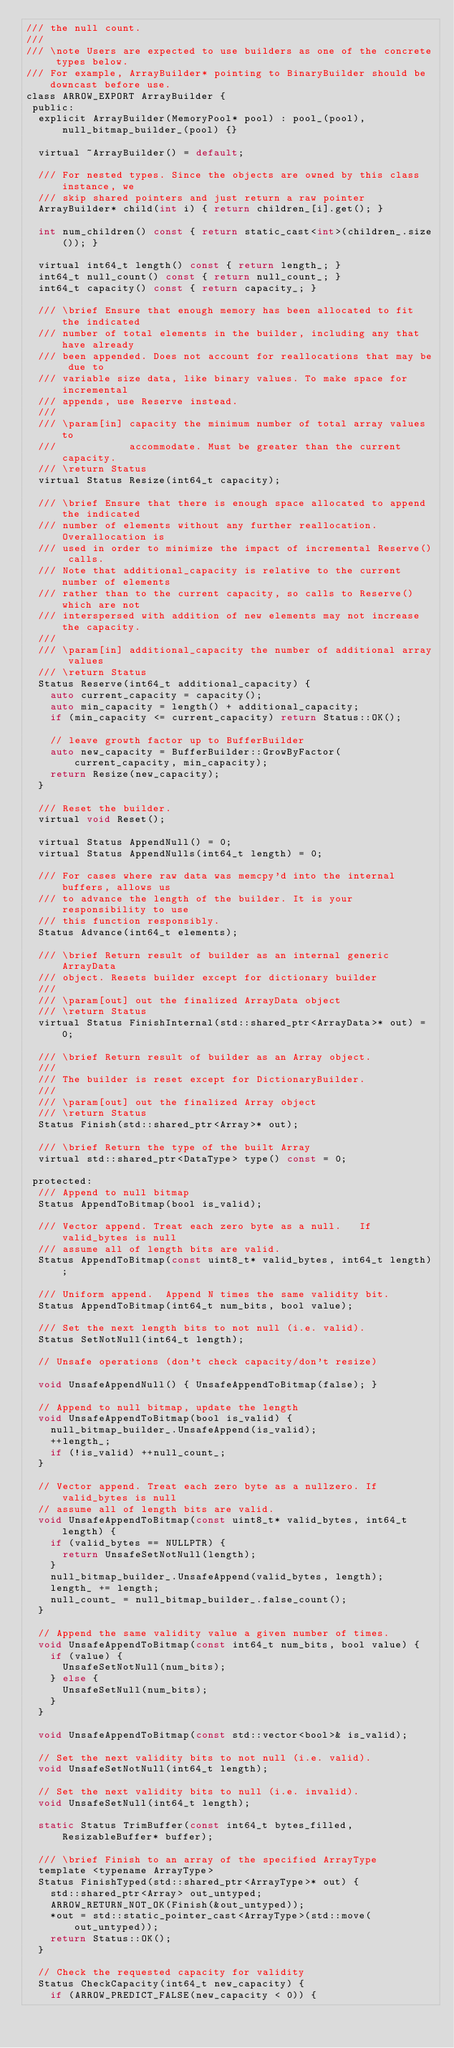Convert code to text. <code><loc_0><loc_0><loc_500><loc_500><_C_>/// the null count.
///
/// \note Users are expected to use builders as one of the concrete types below.
/// For example, ArrayBuilder* pointing to BinaryBuilder should be downcast before use.
class ARROW_EXPORT ArrayBuilder {
 public:
  explicit ArrayBuilder(MemoryPool* pool) : pool_(pool), null_bitmap_builder_(pool) {}

  virtual ~ArrayBuilder() = default;

  /// For nested types. Since the objects are owned by this class instance, we
  /// skip shared pointers and just return a raw pointer
  ArrayBuilder* child(int i) { return children_[i].get(); }

  int num_children() const { return static_cast<int>(children_.size()); }

  virtual int64_t length() const { return length_; }
  int64_t null_count() const { return null_count_; }
  int64_t capacity() const { return capacity_; }

  /// \brief Ensure that enough memory has been allocated to fit the indicated
  /// number of total elements in the builder, including any that have already
  /// been appended. Does not account for reallocations that may be due to
  /// variable size data, like binary values. To make space for incremental
  /// appends, use Reserve instead.
  ///
  /// \param[in] capacity the minimum number of total array values to
  ///            accommodate. Must be greater than the current capacity.
  /// \return Status
  virtual Status Resize(int64_t capacity);

  /// \brief Ensure that there is enough space allocated to append the indicated
  /// number of elements without any further reallocation. Overallocation is
  /// used in order to minimize the impact of incremental Reserve() calls.
  /// Note that additional_capacity is relative to the current number of elements
  /// rather than to the current capacity, so calls to Reserve() which are not
  /// interspersed with addition of new elements may not increase the capacity.
  ///
  /// \param[in] additional_capacity the number of additional array values
  /// \return Status
  Status Reserve(int64_t additional_capacity) {
    auto current_capacity = capacity();
    auto min_capacity = length() + additional_capacity;
    if (min_capacity <= current_capacity) return Status::OK();

    // leave growth factor up to BufferBuilder
    auto new_capacity = BufferBuilder::GrowByFactor(current_capacity, min_capacity);
    return Resize(new_capacity);
  }

  /// Reset the builder.
  virtual void Reset();

  virtual Status AppendNull() = 0;
  virtual Status AppendNulls(int64_t length) = 0;

  /// For cases where raw data was memcpy'd into the internal buffers, allows us
  /// to advance the length of the builder. It is your responsibility to use
  /// this function responsibly.
  Status Advance(int64_t elements);

  /// \brief Return result of builder as an internal generic ArrayData
  /// object. Resets builder except for dictionary builder
  ///
  /// \param[out] out the finalized ArrayData object
  /// \return Status
  virtual Status FinishInternal(std::shared_ptr<ArrayData>* out) = 0;

  /// \brief Return result of builder as an Array object.
  ///
  /// The builder is reset except for DictionaryBuilder.
  ///
  /// \param[out] out the finalized Array object
  /// \return Status
  Status Finish(std::shared_ptr<Array>* out);

  /// \brief Return the type of the built Array
  virtual std::shared_ptr<DataType> type() const = 0;

 protected:
  /// Append to null bitmap
  Status AppendToBitmap(bool is_valid);

  /// Vector append. Treat each zero byte as a null.   If valid_bytes is null
  /// assume all of length bits are valid.
  Status AppendToBitmap(const uint8_t* valid_bytes, int64_t length);

  /// Uniform append.  Append N times the same validity bit.
  Status AppendToBitmap(int64_t num_bits, bool value);

  /// Set the next length bits to not null (i.e. valid).
  Status SetNotNull(int64_t length);

  // Unsafe operations (don't check capacity/don't resize)

  void UnsafeAppendNull() { UnsafeAppendToBitmap(false); }

  // Append to null bitmap, update the length
  void UnsafeAppendToBitmap(bool is_valid) {
    null_bitmap_builder_.UnsafeAppend(is_valid);
    ++length_;
    if (!is_valid) ++null_count_;
  }

  // Vector append. Treat each zero byte as a nullzero. If valid_bytes is null
  // assume all of length bits are valid.
  void UnsafeAppendToBitmap(const uint8_t* valid_bytes, int64_t length) {
    if (valid_bytes == NULLPTR) {
      return UnsafeSetNotNull(length);
    }
    null_bitmap_builder_.UnsafeAppend(valid_bytes, length);
    length_ += length;
    null_count_ = null_bitmap_builder_.false_count();
  }

  // Append the same validity value a given number of times.
  void UnsafeAppendToBitmap(const int64_t num_bits, bool value) {
    if (value) {
      UnsafeSetNotNull(num_bits);
    } else {
      UnsafeSetNull(num_bits);
    }
  }

  void UnsafeAppendToBitmap(const std::vector<bool>& is_valid);

  // Set the next validity bits to not null (i.e. valid).
  void UnsafeSetNotNull(int64_t length);

  // Set the next validity bits to null (i.e. invalid).
  void UnsafeSetNull(int64_t length);

  static Status TrimBuffer(const int64_t bytes_filled, ResizableBuffer* buffer);

  /// \brief Finish to an array of the specified ArrayType
  template <typename ArrayType>
  Status FinishTyped(std::shared_ptr<ArrayType>* out) {
    std::shared_ptr<Array> out_untyped;
    ARROW_RETURN_NOT_OK(Finish(&out_untyped));
    *out = std::static_pointer_cast<ArrayType>(std::move(out_untyped));
    return Status::OK();
  }

  // Check the requested capacity for validity
  Status CheckCapacity(int64_t new_capacity) {
    if (ARROW_PREDICT_FALSE(new_capacity < 0)) {</code> 